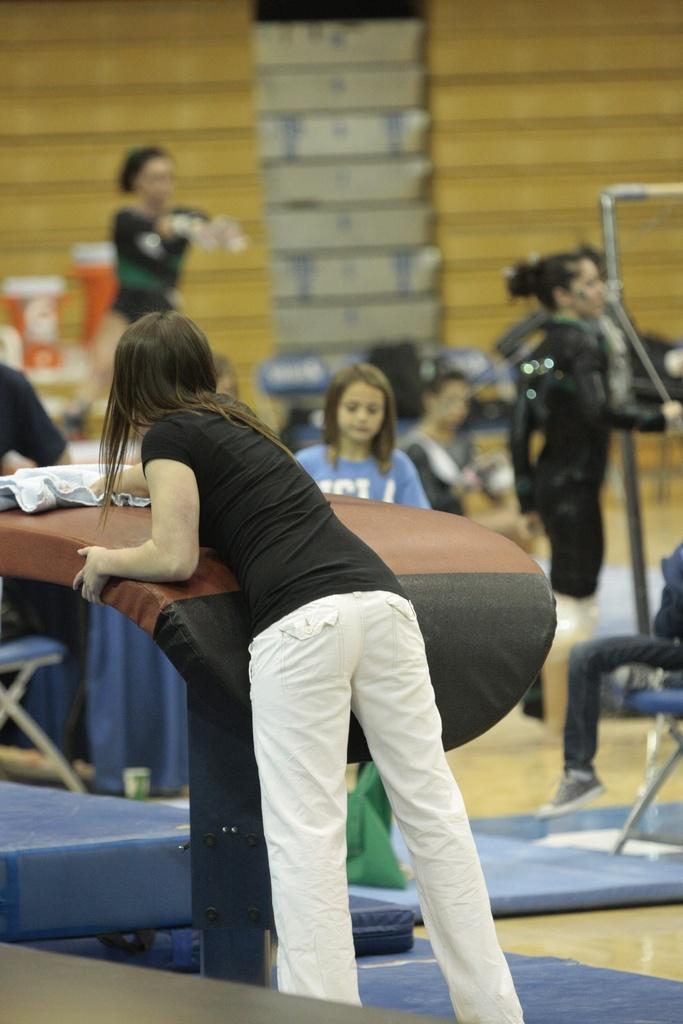Describe this image in one or two sentences. In this image there is a person cleaning the table. Behind her there are few other people. At the bottom of the image there is a floor. There are beds. In the background of the image there are stairs and there are a few objects. 